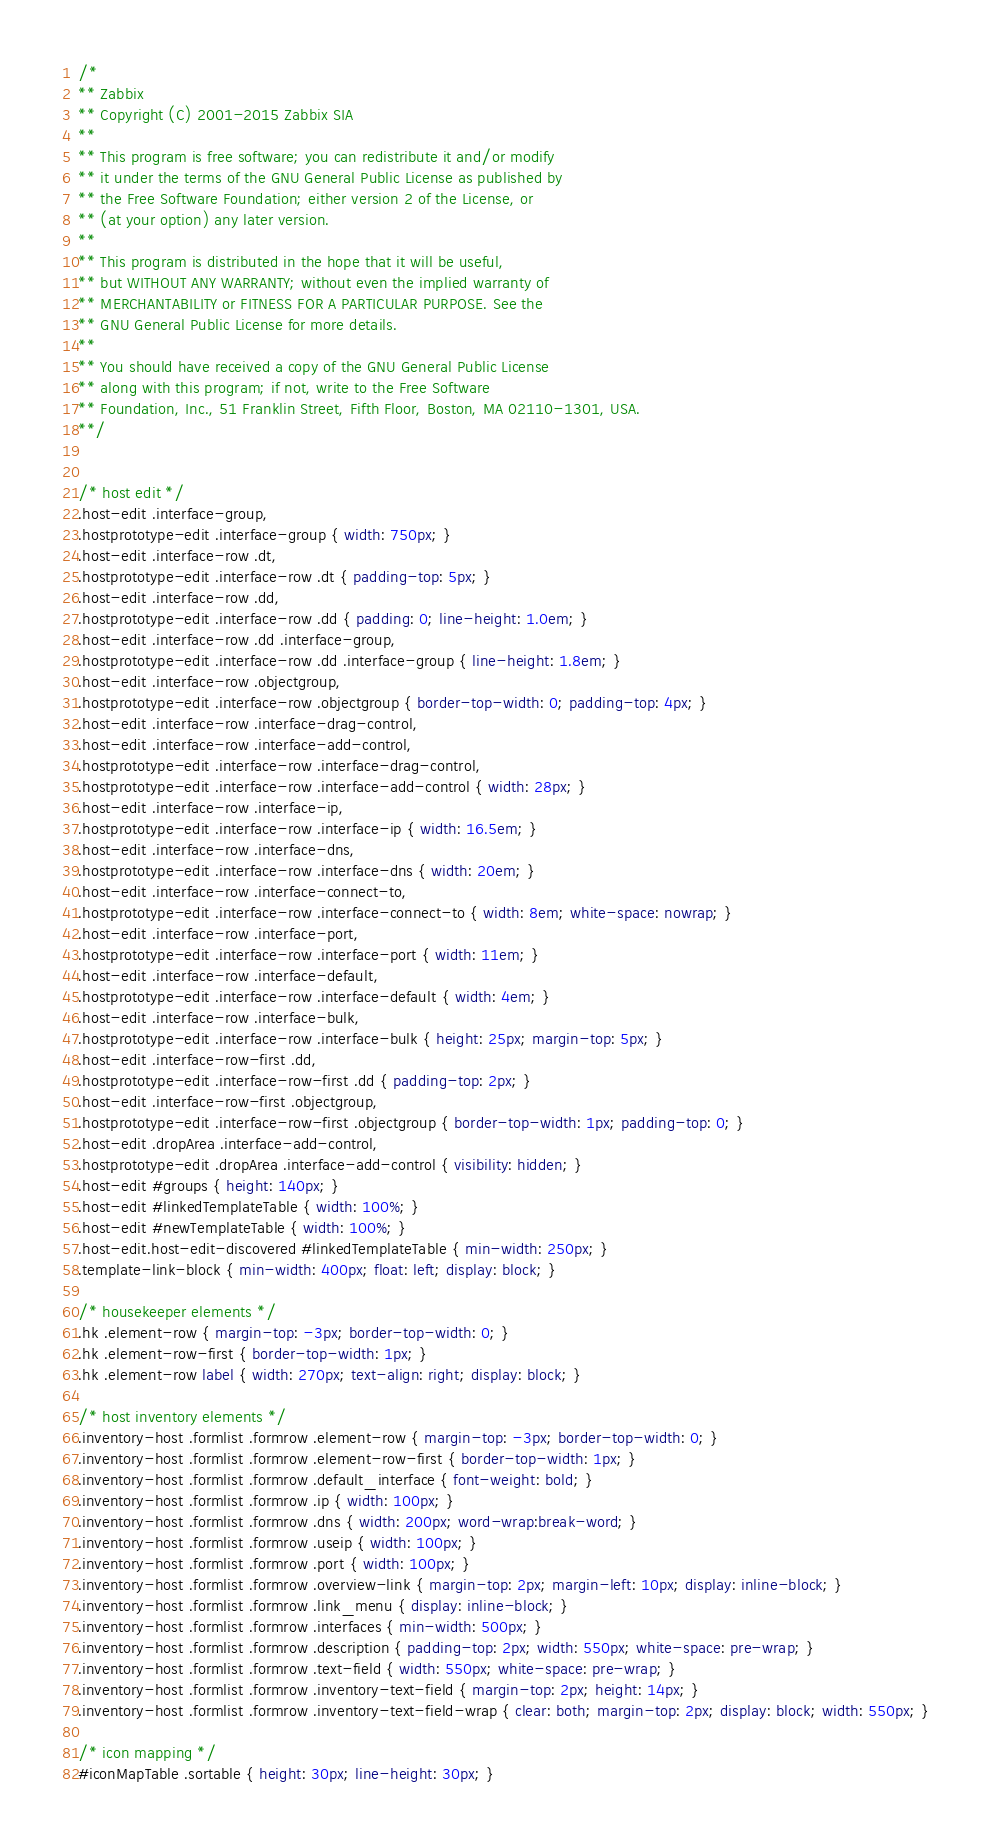Convert code to text. <code><loc_0><loc_0><loc_500><loc_500><_CSS_>/*
** Zabbix
** Copyright (C) 2001-2015 Zabbix SIA
**
** This program is free software; you can redistribute it and/or modify
** it under the terms of the GNU General Public License as published by
** the Free Software Foundation; either version 2 of the License, or
** (at your option) any later version.
**
** This program is distributed in the hope that it will be useful,
** but WITHOUT ANY WARRANTY; without even the implied warranty of
** MERCHANTABILITY or FITNESS FOR A PARTICULAR PURPOSE. See the
** GNU General Public License for more details.
**
** You should have received a copy of the GNU General Public License
** along with this program; if not, write to the Free Software
** Foundation, Inc., 51 Franklin Street, Fifth Floor, Boston, MA 02110-1301, USA.
**/


/* host edit */
.host-edit .interface-group,
.hostprototype-edit .interface-group { width: 750px; }
.host-edit .interface-row .dt,
.hostprototype-edit .interface-row .dt { padding-top: 5px; }
.host-edit .interface-row .dd,
.hostprototype-edit .interface-row .dd { padding: 0; line-height: 1.0em; }
.host-edit .interface-row .dd .interface-group,
.hostprototype-edit .interface-row .dd .interface-group { line-height: 1.8em; }
.host-edit .interface-row .objectgroup,
.hostprototype-edit .interface-row .objectgroup { border-top-width: 0; padding-top: 4px; }
.host-edit .interface-row .interface-drag-control,
.host-edit .interface-row .interface-add-control,
.hostprototype-edit .interface-row .interface-drag-control,
.hostprototype-edit .interface-row .interface-add-control { width: 28px; }
.host-edit .interface-row .interface-ip,
.hostprototype-edit .interface-row .interface-ip { width: 16.5em; }
.host-edit .interface-row .interface-dns,
.hostprototype-edit .interface-row .interface-dns { width: 20em; }
.host-edit .interface-row .interface-connect-to,
.hostprototype-edit .interface-row .interface-connect-to { width: 8em; white-space: nowrap; }
.host-edit .interface-row .interface-port,
.hostprototype-edit .interface-row .interface-port { width: 11em; }
.host-edit .interface-row .interface-default,
.hostprototype-edit .interface-row .interface-default { width: 4em; }
.host-edit .interface-row .interface-bulk,
.hostprototype-edit .interface-row .interface-bulk { height: 25px; margin-top: 5px; }
.host-edit .interface-row-first .dd,
.hostprototype-edit .interface-row-first .dd { padding-top: 2px; }
.host-edit .interface-row-first .objectgroup,
.hostprototype-edit .interface-row-first .objectgroup { border-top-width: 1px; padding-top: 0; }
.host-edit .dropArea .interface-add-control,
.hostprototype-edit .dropArea .interface-add-control { visibility: hidden; }
.host-edit #groups { height: 140px; }
.host-edit #linkedTemplateTable { width: 100%; }
.host-edit #newTemplateTable { width: 100%; }
.host-edit.host-edit-discovered #linkedTemplateTable { min-width: 250px; }
.template-link-block { min-width: 400px; float: left; display: block; }

/* housekeeper elements */
.hk .element-row { margin-top: -3px; border-top-width: 0; }
.hk .element-row-first { border-top-width: 1px; }
.hk .element-row label { width: 270px; text-align: right; display: block; }

/* host inventory elements */
.inventory-host .formlist .formrow .element-row { margin-top: -3px; border-top-width: 0; }
.inventory-host .formlist .formrow .element-row-first { border-top-width: 1px; }
.inventory-host .formlist .formrow .default_interface { font-weight: bold; }
.inventory-host .formlist .formrow .ip { width: 100px; }
.inventory-host .formlist .formrow .dns { width: 200px; word-wrap:break-word; }
.inventory-host .formlist .formrow .useip { width: 100px; }
.inventory-host .formlist .formrow .port { width: 100px; }
.inventory-host .formlist .formrow .overview-link { margin-top: 2px; margin-left: 10px; display: inline-block; }
.inventory-host .formlist .formrow .link_menu { display: inline-block; }
.inventory-host .formlist .formrow .interfaces { min-width: 500px; }
.inventory-host .formlist .formrow .description { padding-top: 2px; width: 550px; white-space: pre-wrap; }
.inventory-host .formlist .formrow .text-field { width: 550px; white-space: pre-wrap; }
.inventory-host .formlist .formrow .inventory-text-field { margin-top: 2px; height: 14px; }
.inventory-host .formlist .formrow .inventory-text-field-wrap { clear: both; margin-top: 2px; display: block; width: 550px; }

/* icon mapping */
#iconMapTable .sortable { height: 30px; line-height: 30px; }</code> 